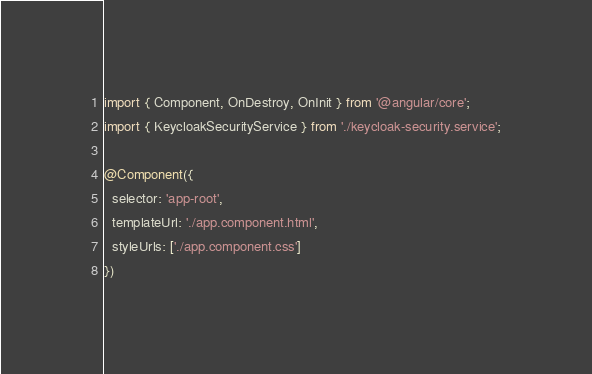Convert code to text. <code><loc_0><loc_0><loc_500><loc_500><_TypeScript_>import { Component, OnDestroy, OnInit } from '@angular/core';
import { KeycloakSecurityService } from './keycloak-security.service';

@Component({
  selector: 'app-root',
  templateUrl: './app.component.html',
  styleUrls: ['./app.component.css']
})</code> 